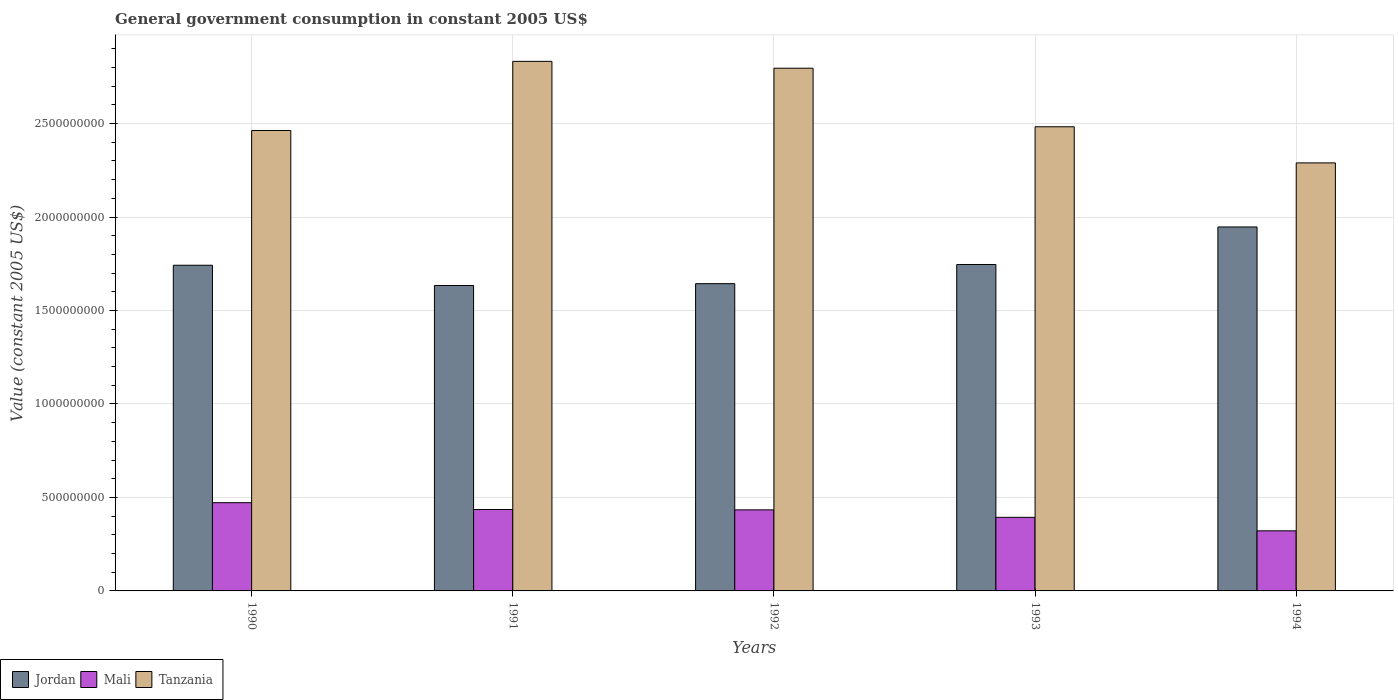How many different coloured bars are there?
Give a very brief answer. 3. Are the number of bars per tick equal to the number of legend labels?
Offer a terse response. Yes. How many bars are there on the 1st tick from the left?
Offer a very short reply. 3. How many bars are there on the 4th tick from the right?
Your answer should be very brief. 3. In how many cases, is the number of bars for a given year not equal to the number of legend labels?
Provide a succinct answer. 0. What is the government conusmption in Mali in 1991?
Offer a terse response. 4.35e+08. Across all years, what is the maximum government conusmption in Mali?
Provide a short and direct response. 4.72e+08. Across all years, what is the minimum government conusmption in Tanzania?
Your answer should be very brief. 2.29e+09. What is the total government conusmption in Jordan in the graph?
Provide a short and direct response. 8.71e+09. What is the difference between the government conusmption in Tanzania in 1991 and that in 1994?
Ensure brevity in your answer.  5.43e+08. What is the difference between the government conusmption in Mali in 1991 and the government conusmption in Tanzania in 1994?
Your answer should be very brief. -1.85e+09. What is the average government conusmption in Mali per year?
Keep it short and to the point. 4.11e+08. In the year 1990, what is the difference between the government conusmption in Mali and government conusmption in Tanzania?
Give a very brief answer. -1.99e+09. What is the ratio of the government conusmption in Jordan in 1992 to that in 1993?
Keep it short and to the point. 0.94. Is the government conusmption in Tanzania in 1992 less than that in 1994?
Ensure brevity in your answer.  No. What is the difference between the highest and the second highest government conusmption in Tanzania?
Make the answer very short. 3.67e+07. What is the difference between the highest and the lowest government conusmption in Tanzania?
Your answer should be compact. 5.43e+08. In how many years, is the government conusmption in Jordan greater than the average government conusmption in Jordan taken over all years?
Keep it short and to the point. 2. Is the sum of the government conusmption in Tanzania in 1991 and 1994 greater than the maximum government conusmption in Jordan across all years?
Make the answer very short. Yes. What does the 3rd bar from the left in 1993 represents?
Provide a short and direct response. Tanzania. What does the 3rd bar from the right in 1992 represents?
Keep it short and to the point. Jordan. How many bars are there?
Keep it short and to the point. 15. How many years are there in the graph?
Your answer should be compact. 5. Are the values on the major ticks of Y-axis written in scientific E-notation?
Ensure brevity in your answer.  No. Does the graph contain any zero values?
Keep it short and to the point. No. Where does the legend appear in the graph?
Offer a terse response. Bottom left. How many legend labels are there?
Your answer should be very brief. 3. How are the legend labels stacked?
Your answer should be compact. Horizontal. What is the title of the graph?
Provide a succinct answer. General government consumption in constant 2005 US$. Does "Antigua and Barbuda" appear as one of the legend labels in the graph?
Your answer should be very brief. No. What is the label or title of the Y-axis?
Your answer should be very brief. Value (constant 2005 US$). What is the Value (constant 2005 US$) of Jordan in 1990?
Provide a succinct answer. 1.74e+09. What is the Value (constant 2005 US$) in Mali in 1990?
Your response must be concise. 4.72e+08. What is the Value (constant 2005 US$) in Tanzania in 1990?
Give a very brief answer. 2.46e+09. What is the Value (constant 2005 US$) in Jordan in 1991?
Offer a terse response. 1.63e+09. What is the Value (constant 2005 US$) of Mali in 1991?
Give a very brief answer. 4.35e+08. What is the Value (constant 2005 US$) of Tanzania in 1991?
Provide a short and direct response. 2.83e+09. What is the Value (constant 2005 US$) in Jordan in 1992?
Your answer should be very brief. 1.64e+09. What is the Value (constant 2005 US$) of Mali in 1992?
Your response must be concise. 4.34e+08. What is the Value (constant 2005 US$) of Tanzania in 1992?
Make the answer very short. 2.80e+09. What is the Value (constant 2005 US$) of Jordan in 1993?
Your answer should be compact. 1.75e+09. What is the Value (constant 2005 US$) in Mali in 1993?
Your response must be concise. 3.94e+08. What is the Value (constant 2005 US$) in Tanzania in 1993?
Your answer should be very brief. 2.48e+09. What is the Value (constant 2005 US$) of Jordan in 1994?
Give a very brief answer. 1.95e+09. What is the Value (constant 2005 US$) of Mali in 1994?
Your answer should be very brief. 3.21e+08. What is the Value (constant 2005 US$) of Tanzania in 1994?
Your response must be concise. 2.29e+09. Across all years, what is the maximum Value (constant 2005 US$) of Jordan?
Provide a short and direct response. 1.95e+09. Across all years, what is the maximum Value (constant 2005 US$) of Mali?
Your answer should be compact. 4.72e+08. Across all years, what is the maximum Value (constant 2005 US$) in Tanzania?
Your answer should be very brief. 2.83e+09. Across all years, what is the minimum Value (constant 2005 US$) in Jordan?
Offer a very short reply. 1.63e+09. Across all years, what is the minimum Value (constant 2005 US$) in Mali?
Your response must be concise. 3.21e+08. Across all years, what is the minimum Value (constant 2005 US$) in Tanzania?
Make the answer very short. 2.29e+09. What is the total Value (constant 2005 US$) of Jordan in the graph?
Keep it short and to the point. 8.71e+09. What is the total Value (constant 2005 US$) in Mali in the graph?
Your answer should be very brief. 2.06e+09. What is the total Value (constant 2005 US$) of Tanzania in the graph?
Provide a short and direct response. 1.29e+1. What is the difference between the Value (constant 2005 US$) in Jordan in 1990 and that in 1991?
Your response must be concise. 1.08e+08. What is the difference between the Value (constant 2005 US$) in Mali in 1990 and that in 1991?
Give a very brief answer. 3.65e+07. What is the difference between the Value (constant 2005 US$) of Tanzania in 1990 and that in 1991?
Your response must be concise. -3.70e+08. What is the difference between the Value (constant 2005 US$) of Jordan in 1990 and that in 1992?
Offer a very short reply. 9.85e+07. What is the difference between the Value (constant 2005 US$) in Mali in 1990 and that in 1992?
Ensure brevity in your answer.  3.84e+07. What is the difference between the Value (constant 2005 US$) in Tanzania in 1990 and that in 1992?
Offer a very short reply. -3.33e+08. What is the difference between the Value (constant 2005 US$) of Jordan in 1990 and that in 1993?
Offer a terse response. -4.03e+06. What is the difference between the Value (constant 2005 US$) in Mali in 1990 and that in 1993?
Keep it short and to the point. 7.83e+07. What is the difference between the Value (constant 2005 US$) in Tanzania in 1990 and that in 1993?
Offer a very short reply. -2.01e+07. What is the difference between the Value (constant 2005 US$) in Jordan in 1990 and that in 1994?
Your answer should be very brief. -2.05e+08. What is the difference between the Value (constant 2005 US$) of Mali in 1990 and that in 1994?
Provide a short and direct response. 1.51e+08. What is the difference between the Value (constant 2005 US$) of Tanzania in 1990 and that in 1994?
Provide a succinct answer. 1.73e+08. What is the difference between the Value (constant 2005 US$) of Jordan in 1991 and that in 1992?
Provide a short and direct response. -9.79e+06. What is the difference between the Value (constant 2005 US$) of Mali in 1991 and that in 1992?
Your answer should be very brief. 1.86e+06. What is the difference between the Value (constant 2005 US$) of Tanzania in 1991 and that in 1992?
Your answer should be compact. 3.67e+07. What is the difference between the Value (constant 2005 US$) of Jordan in 1991 and that in 1993?
Offer a terse response. -1.12e+08. What is the difference between the Value (constant 2005 US$) in Mali in 1991 and that in 1993?
Your answer should be compact. 4.18e+07. What is the difference between the Value (constant 2005 US$) in Tanzania in 1991 and that in 1993?
Ensure brevity in your answer.  3.50e+08. What is the difference between the Value (constant 2005 US$) in Jordan in 1991 and that in 1994?
Keep it short and to the point. -3.13e+08. What is the difference between the Value (constant 2005 US$) of Mali in 1991 and that in 1994?
Provide a succinct answer. 1.14e+08. What is the difference between the Value (constant 2005 US$) of Tanzania in 1991 and that in 1994?
Offer a terse response. 5.43e+08. What is the difference between the Value (constant 2005 US$) in Jordan in 1992 and that in 1993?
Your answer should be very brief. -1.02e+08. What is the difference between the Value (constant 2005 US$) of Mali in 1992 and that in 1993?
Provide a succinct answer. 4.00e+07. What is the difference between the Value (constant 2005 US$) in Tanzania in 1992 and that in 1993?
Your response must be concise. 3.13e+08. What is the difference between the Value (constant 2005 US$) of Jordan in 1992 and that in 1994?
Make the answer very short. -3.03e+08. What is the difference between the Value (constant 2005 US$) of Mali in 1992 and that in 1994?
Your answer should be very brief. 1.12e+08. What is the difference between the Value (constant 2005 US$) of Tanzania in 1992 and that in 1994?
Your answer should be compact. 5.06e+08. What is the difference between the Value (constant 2005 US$) in Jordan in 1993 and that in 1994?
Provide a succinct answer. -2.01e+08. What is the difference between the Value (constant 2005 US$) in Mali in 1993 and that in 1994?
Your response must be concise. 7.22e+07. What is the difference between the Value (constant 2005 US$) of Tanzania in 1993 and that in 1994?
Provide a short and direct response. 1.93e+08. What is the difference between the Value (constant 2005 US$) in Jordan in 1990 and the Value (constant 2005 US$) in Mali in 1991?
Provide a short and direct response. 1.31e+09. What is the difference between the Value (constant 2005 US$) in Jordan in 1990 and the Value (constant 2005 US$) in Tanzania in 1991?
Make the answer very short. -1.09e+09. What is the difference between the Value (constant 2005 US$) in Mali in 1990 and the Value (constant 2005 US$) in Tanzania in 1991?
Offer a terse response. -2.36e+09. What is the difference between the Value (constant 2005 US$) in Jordan in 1990 and the Value (constant 2005 US$) in Mali in 1992?
Your response must be concise. 1.31e+09. What is the difference between the Value (constant 2005 US$) of Jordan in 1990 and the Value (constant 2005 US$) of Tanzania in 1992?
Make the answer very short. -1.05e+09. What is the difference between the Value (constant 2005 US$) in Mali in 1990 and the Value (constant 2005 US$) in Tanzania in 1992?
Your response must be concise. -2.32e+09. What is the difference between the Value (constant 2005 US$) in Jordan in 1990 and the Value (constant 2005 US$) in Mali in 1993?
Give a very brief answer. 1.35e+09. What is the difference between the Value (constant 2005 US$) of Jordan in 1990 and the Value (constant 2005 US$) of Tanzania in 1993?
Your answer should be compact. -7.41e+08. What is the difference between the Value (constant 2005 US$) in Mali in 1990 and the Value (constant 2005 US$) in Tanzania in 1993?
Offer a terse response. -2.01e+09. What is the difference between the Value (constant 2005 US$) of Jordan in 1990 and the Value (constant 2005 US$) of Mali in 1994?
Your response must be concise. 1.42e+09. What is the difference between the Value (constant 2005 US$) of Jordan in 1990 and the Value (constant 2005 US$) of Tanzania in 1994?
Offer a very short reply. -5.47e+08. What is the difference between the Value (constant 2005 US$) in Mali in 1990 and the Value (constant 2005 US$) in Tanzania in 1994?
Your response must be concise. -1.82e+09. What is the difference between the Value (constant 2005 US$) of Jordan in 1991 and the Value (constant 2005 US$) of Mali in 1992?
Provide a short and direct response. 1.20e+09. What is the difference between the Value (constant 2005 US$) in Jordan in 1991 and the Value (constant 2005 US$) in Tanzania in 1992?
Provide a short and direct response. -1.16e+09. What is the difference between the Value (constant 2005 US$) in Mali in 1991 and the Value (constant 2005 US$) in Tanzania in 1992?
Provide a succinct answer. -2.36e+09. What is the difference between the Value (constant 2005 US$) of Jordan in 1991 and the Value (constant 2005 US$) of Mali in 1993?
Offer a terse response. 1.24e+09. What is the difference between the Value (constant 2005 US$) of Jordan in 1991 and the Value (constant 2005 US$) of Tanzania in 1993?
Make the answer very short. -8.49e+08. What is the difference between the Value (constant 2005 US$) in Mali in 1991 and the Value (constant 2005 US$) in Tanzania in 1993?
Ensure brevity in your answer.  -2.05e+09. What is the difference between the Value (constant 2005 US$) of Jordan in 1991 and the Value (constant 2005 US$) of Mali in 1994?
Make the answer very short. 1.31e+09. What is the difference between the Value (constant 2005 US$) of Jordan in 1991 and the Value (constant 2005 US$) of Tanzania in 1994?
Ensure brevity in your answer.  -6.56e+08. What is the difference between the Value (constant 2005 US$) in Mali in 1991 and the Value (constant 2005 US$) in Tanzania in 1994?
Your response must be concise. -1.85e+09. What is the difference between the Value (constant 2005 US$) of Jordan in 1992 and the Value (constant 2005 US$) of Mali in 1993?
Give a very brief answer. 1.25e+09. What is the difference between the Value (constant 2005 US$) in Jordan in 1992 and the Value (constant 2005 US$) in Tanzania in 1993?
Give a very brief answer. -8.39e+08. What is the difference between the Value (constant 2005 US$) of Mali in 1992 and the Value (constant 2005 US$) of Tanzania in 1993?
Offer a terse response. -2.05e+09. What is the difference between the Value (constant 2005 US$) of Jordan in 1992 and the Value (constant 2005 US$) of Mali in 1994?
Offer a terse response. 1.32e+09. What is the difference between the Value (constant 2005 US$) of Jordan in 1992 and the Value (constant 2005 US$) of Tanzania in 1994?
Provide a short and direct response. -6.46e+08. What is the difference between the Value (constant 2005 US$) of Mali in 1992 and the Value (constant 2005 US$) of Tanzania in 1994?
Provide a short and direct response. -1.86e+09. What is the difference between the Value (constant 2005 US$) in Jordan in 1993 and the Value (constant 2005 US$) in Mali in 1994?
Give a very brief answer. 1.42e+09. What is the difference between the Value (constant 2005 US$) of Jordan in 1993 and the Value (constant 2005 US$) of Tanzania in 1994?
Provide a short and direct response. -5.43e+08. What is the difference between the Value (constant 2005 US$) of Mali in 1993 and the Value (constant 2005 US$) of Tanzania in 1994?
Provide a short and direct response. -1.90e+09. What is the average Value (constant 2005 US$) in Jordan per year?
Make the answer very short. 1.74e+09. What is the average Value (constant 2005 US$) of Mali per year?
Your response must be concise. 4.11e+08. What is the average Value (constant 2005 US$) of Tanzania per year?
Provide a succinct answer. 2.57e+09. In the year 1990, what is the difference between the Value (constant 2005 US$) of Jordan and Value (constant 2005 US$) of Mali?
Your answer should be very brief. 1.27e+09. In the year 1990, what is the difference between the Value (constant 2005 US$) in Jordan and Value (constant 2005 US$) in Tanzania?
Make the answer very short. -7.21e+08. In the year 1990, what is the difference between the Value (constant 2005 US$) in Mali and Value (constant 2005 US$) in Tanzania?
Provide a short and direct response. -1.99e+09. In the year 1991, what is the difference between the Value (constant 2005 US$) of Jordan and Value (constant 2005 US$) of Mali?
Offer a very short reply. 1.20e+09. In the year 1991, what is the difference between the Value (constant 2005 US$) of Jordan and Value (constant 2005 US$) of Tanzania?
Provide a succinct answer. -1.20e+09. In the year 1991, what is the difference between the Value (constant 2005 US$) in Mali and Value (constant 2005 US$) in Tanzania?
Offer a terse response. -2.40e+09. In the year 1992, what is the difference between the Value (constant 2005 US$) in Jordan and Value (constant 2005 US$) in Mali?
Your response must be concise. 1.21e+09. In the year 1992, what is the difference between the Value (constant 2005 US$) of Jordan and Value (constant 2005 US$) of Tanzania?
Ensure brevity in your answer.  -1.15e+09. In the year 1992, what is the difference between the Value (constant 2005 US$) of Mali and Value (constant 2005 US$) of Tanzania?
Your answer should be very brief. -2.36e+09. In the year 1993, what is the difference between the Value (constant 2005 US$) of Jordan and Value (constant 2005 US$) of Mali?
Ensure brevity in your answer.  1.35e+09. In the year 1993, what is the difference between the Value (constant 2005 US$) of Jordan and Value (constant 2005 US$) of Tanzania?
Ensure brevity in your answer.  -7.37e+08. In the year 1993, what is the difference between the Value (constant 2005 US$) in Mali and Value (constant 2005 US$) in Tanzania?
Keep it short and to the point. -2.09e+09. In the year 1994, what is the difference between the Value (constant 2005 US$) of Jordan and Value (constant 2005 US$) of Mali?
Offer a very short reply. 1.63e+09. In the year 1994, what is the difference between the Value (constant 2005 US$) of Jordan and Value (constant 2005 US$) of Tanzania?
Provide a succinct answer. -3.43e+08. In the year 1994, what is the difference between the Value (constant 2005 US$) in Mali and Value (constant 2005 US$) in Tanzania?
Your answer should be very brief. -1.97e+09. What is the ratio of the Value (constant 2005 US$) of Jordan in 1990 to that in 1991?
Offer a very short reply. 1.07. What is the ratio of the Value (constant 2005 US$) of Mali in 1990 to that in 1991?
Give a very brief answer. 1.08. What is the ratio of the Value (constant 2005 US$) of Tanzania in 1990 to that in 1991?
Provide a succinct answer. 0.87. What is the ratio of the Value (constant 2005 US$) in Jordan in 1990 to that in 1992?
Your answer should be very brief. 1.06. What is the ratio of the Value (constant 2005 US$) of Mali in 1990 to that in 1992?
Your answer should be compact. 1.09. What is the ratio of the Value (constant 2005 US$) in Tanzania in 1990 to that in 1992?
Your response must be concise. 0.88. What is the ratio of the Value (constant 2005 US$) in Mali in 1990 to that in 1993?
Your response must be concise. 1.2. What is the ratio of the Value (constant 2005 US$) in Jordan in 1990 to that in 1994?
Ensure brevity in your answer.  0.89. What is the ratio of the Value (constant 2005 US$) in Mali in 1990 to that in 1994?
Your answer should be compact. 1.47. What is the ratio of the Value (constant 2005 US$) in Tanzania in 1990 to that in 1994?
Provide a succinct answer. 1.08. What is the ratio of the Value (constant 2005 US$) in Jordan in 1991 to that in 1992?
Ensure brevity in your answer.  0.99. What is the ratio of the Value (constant 2005 US$) of Tanzania in 1991 to that in 1992?
Provide a short and direct response. 1.01. What is the ratio of the Value (constant 2005 US$) of Jordan in 1991 to that in 1993?
Give a very brief answer. 0.94. What is the ratio of the Value (constant 2005 US$) of Mali in 1991 to that in 1993?
Your answer should be very brief. 1.11. What is the ratio of the Value (constant 2005 US$) in Tanzania in 1991 to that in 1993?
Your answer should be compact. 1.14. What is the ratio of the Value (constant 2005 US$) in Jordan in 1991 to that in 1994?
Your answer should be compact. 0.84. What is the ratio of the Value (constant 2005 US$) in Mali in 1991 to that in 1994?
Your answer should be compact. 1.35. What is the ratio of the Value (constant 2005 US$) in Tanzania in 1991 to that in 1994?
Provide a succinct answer. 1.24. What is the ratio of the Value (constant 2005 US$) in Jordan in 1992 to that in 1993?
Your answer should be compact. 0.94. What is the ratio of the Value (constant 2005 US$) in Mali in 1992 to that in 1993?
Offer a very short reply. 1.1. What is the ratio of the Value (constant 2005 US$) of Tanzania in 1992 to that in 1993?
Your response must be concise. 1.13. What is the ratio of the Value (constant 2005 US$) in Jordan in 1992 to that in 1994?
Make the answer very short. 0.84. What is the ratio of the Value (constant 2005 US$) in Mali in 1992 to that in 1994?
Provide a short and direct response. 1.35. What is the ratio of the Value (constant 2005 US$) of Tanzania in 1992 to that in 1994?
Provide a succinct answer. 1.22. What is the ratio of the Value (constant 2005 US$) of Jordan in 1993 to that in 1994?
Your answer should be very brief. 0.9. What is the ratio of the Value (constant 2005 US$) in Mali in 1993 to that in 1994?
Provide a succinct answer. 1.22. What is the ratio of the Value (constant 2005 US$) in Tanzania in 1993 to that in 1994?
Offer a terse response. 1.08. What is the difference between the highest and the second highest Value (constant 2005 US$) in Jordan?
Your answer should be compact. 2.01e+08. What is the difference between the highest and the second highest Value (constant 2005 US$) in Mali?
Offer a terse response. 3.65e+07. What is the difference between the highest and the second highest Value (constant 2005 US$) in Tanzania?
Make the answer very short. 3.67e+07. What is the difference between the highest and the lowest Value (constant 2005 US$) of Jordan?
Your answer should be very brief. 3.13e+08. What is the difference between the highest and the lowest Value (constant 2005 US$) in Mali?
Your answer should be very brief. 1.51e+08. What is the difference between the highest and the lowest Value (constant 2005 US$) in Tanzania?
Ensure brevity in your answer.  5.43e+08. 